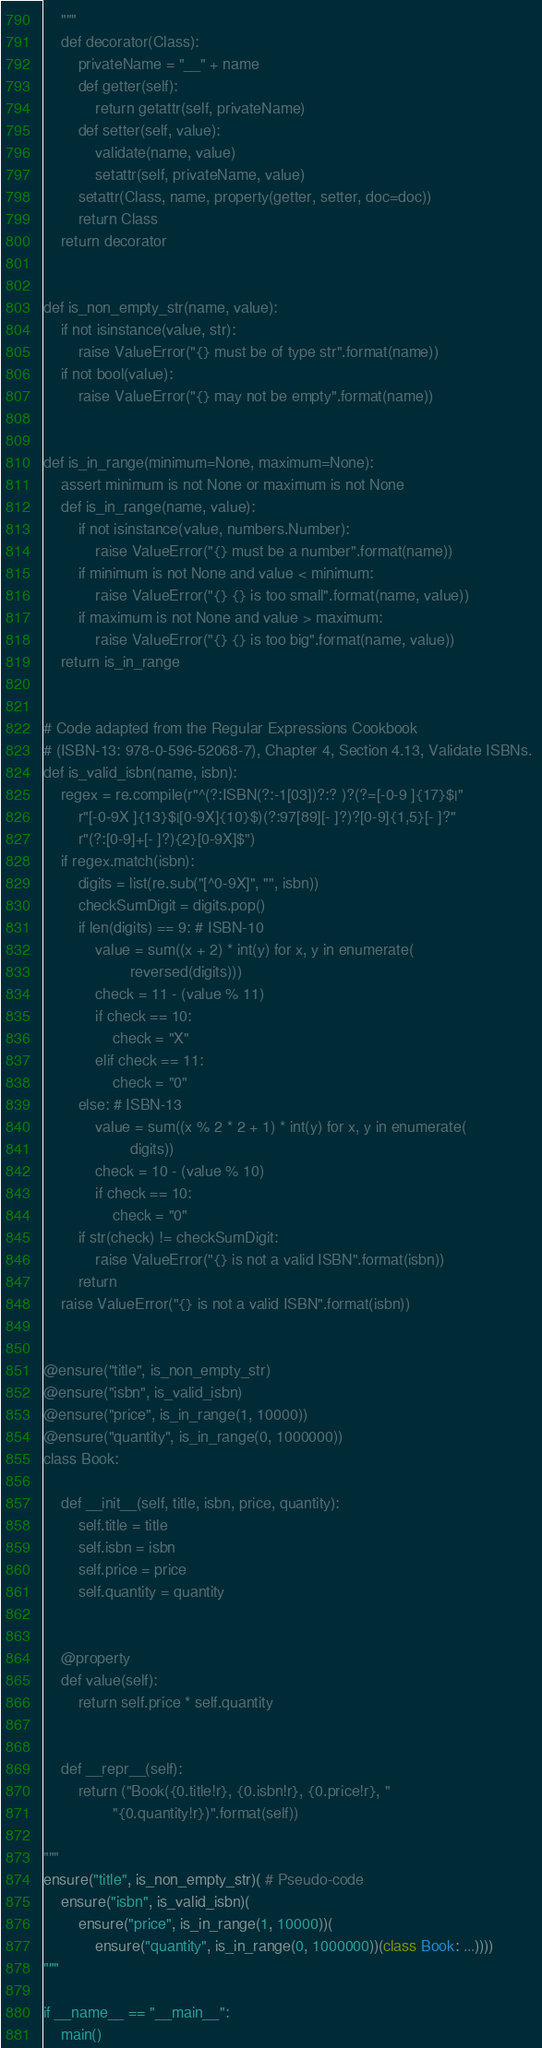<code> <loc_0><loc_0><loc_500><loc_500><_Python_>    """
    def decorator(Class):
        privateName = "__" + name
        def getter(self):
            return getattr(self, privateName)
        def setter(self, value):
            validate(name, value)
            setattr(self, privateName, value)
        setattr(Class, name, property(getter, setter, doc=doc))
        return Class
    return decorator


def is_non_empty_str(name, value):
    if not isinstance(value, str):
        raise ValueError("{} must be of type str".format(name))
    if not bool(value):
        raise ValueError("{} may not be empty".format(name))


def is_in_range(minimum=None, maximum=None):
    assert minimum is not None or maximum is not None
    def is_in_range(name, value):
        if not isinstance(value, numbers.Number):
            raise ValueError("{} must be a number".format(name))
        if minimum is not None and value < minimum:
            raise ValueError("{} {} is too small".format(name, value))
        if maximum is not None and value > maximum:
            raise ValueError("{} {} is too big".format(name, value))
    return is_in_range


# Code adapted from the Regular Expressions Cookbook
# (ISBN-13: 978-0-596-52068-7), Chapter 4, Section 4.13, Validate ISBNs. 
def is_valid_isbn(name, isbn):
    regex = re.compile(r"^(?:ISBN(?:-1[03])?:? )?(?=[-0-9 ]{17}$|"
        r"[-0-9X ]{13}$|[0-9X]{10}$)(?:97[89][- ]?)?[0-9]{1,5}[- ]?"
        r"(?:[0-9]+[- ]?){2}[0-9X]$")
    if regex.match(isbn):
        digits = list(re.sub("[^0-9X]", "", isbn))
        checkSumDigit = digits.pop()
        if len(digits) == 9: # ISBN-10
            value = sum((x + 2) * int(y) for x, y in enumerate(
                    reversed(digits)))
            check = 11 - (value % 11)
            if check == 10:
                check = "X"
            elif check == 11:
                check = "0"
        else: # ISBN-13
            value = sum((x % 2 * 2 + 1) * int(y) for x, y in enumerate(
                    digits))
            check = 10 - (value % 10)
            if check == 10:
                check = "0"
        if str(check) != checkSumDigit:
            raise ValueError("{} is not a valid ISBN".format(isbn))
        return
    raise ValueError("{} is not a valid ISBN".format(isbn))


@ensure("title", is_non_empty_str)
@ensure("isbn", is_valid_isbn)
@ensure("price", is_in_range(1, 10000))
@ensure("quantity", is_in_range(0, 1000000))
class Book:

    def __init__(self, title, isbn, price, quantity):
        self.title = title
        self.isbn = isbn
        self.price = price
        self.quantity = quantity


    @property
    def value(self):
        return self.price * self.quantity


    def __repr__(self):
        return ("Book({0.title!r}, {0.isbn!r}, {0.price!r}, "
                "{0.quantity!r})".format(self))

"""
ensure("title", is_non_empty_str)( # Pseudo-code
    ensure("isbn", is_valid_isbn)(
        ensure("price", is_in_range(1, 10000))(
            ensure("quantity", is_in_range(0, 1000000))(class Book: ...))))
"""

if __name__ == "__main__":
    main()
</code> 